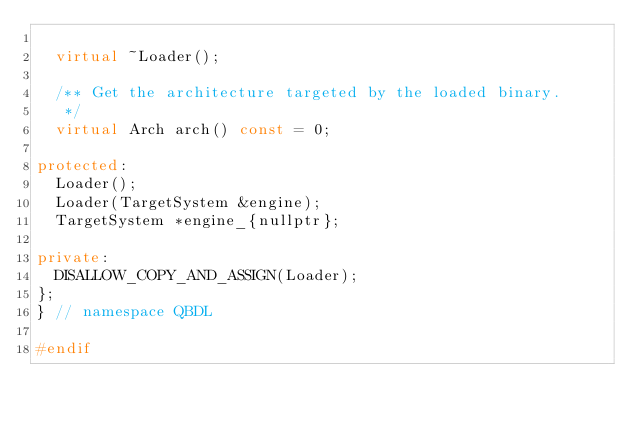<code> <loc_0><loc_0><loc_500><loc_500><_C++_>
  virtual ~Loader();

  /** Get the architecture targeted by the loaded binary.
   */
  virtual Arch arch() const = 0;

protected:
  Loader();
  Loader(TargetSystem &engine);
  TargetSystem *engine_{nullptr};

private:
  DISALLOW_COPY_AND_ASSIGN(Loader);
};
} // namespace QBDL

#endif
</code> 